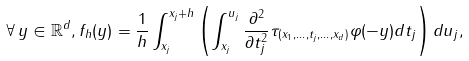Convert formula to latex. <formula><loc_0><loc_0><loc_500><loc_500>\forall \, y \in \mathbb { R } ^ { d } , f _ { h } ( y ) = \frac { 1 } { h } \int ^ { x _ { j } + h } _ { x _ { j } } \left ( \int ^ { u _ { j } } _ { x _ { j } } \frac { \partial ^ { 2 } } { \partial t ^ { 2 } _ { j } } \tau _ { ( x _ { 1 } , \dots , t _ { j } , \dots , x _ { d } ) } \varphi ( - y ) d t _ { j } \right ) d u _ { j } ,</formula> 